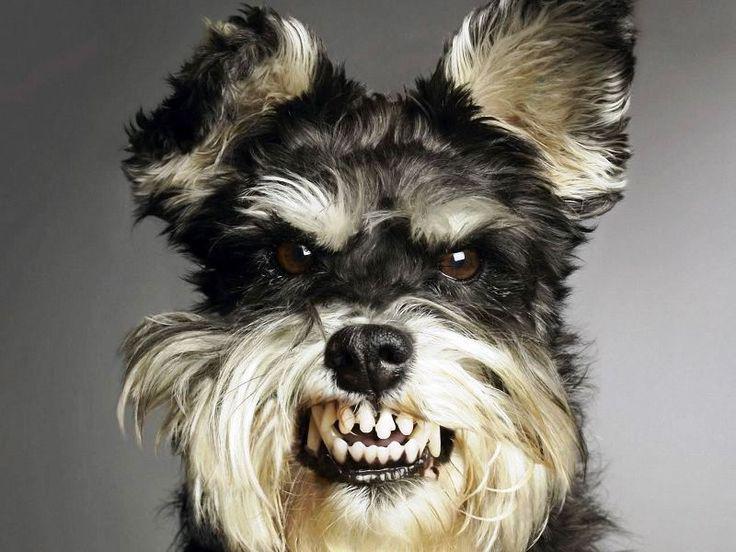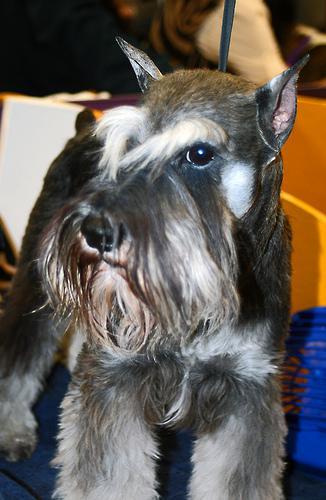The first image is the image on the left, the second image is the image on the right. Analyze the images presented: Is the assertion "One image shows a dog standing upright with at least one paw propped on something flat, and the other image includes at least two schnauzers." valid? Answer yes or no. No. The first image is the image on the left, the second image is the image on the right. Examine the images to the left and right. Is the description "One dog's teeth are visible." accurate? Answer yes or no. Yes. 